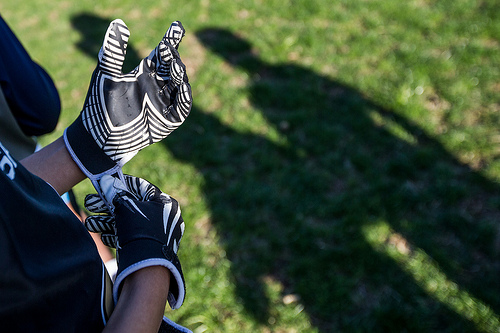<image>
Can you confirm if the glove is above the ground? Yes. The glove is positioned above the ground in the vertical space, higher up in the scene. Is the glove on the shadow? Yes. Looking at the image, I can see the glove is positioned on top of the shadow, with the shadow providing support. 